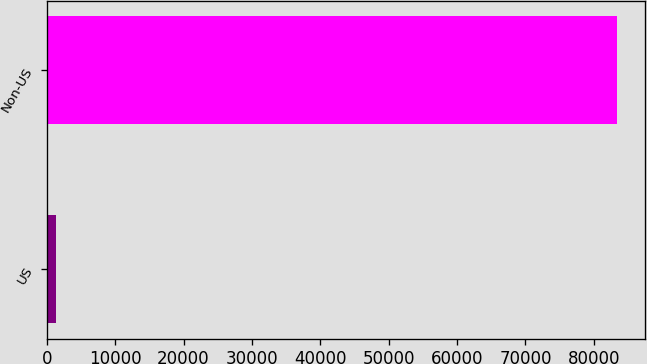Convert chart. <chart><loc_0><loc_0><loc_500><loc_500><bar_chart><fcel>US<fcel>Non-US<nl><fcel>1290<fcel>83378<nl></chart> 